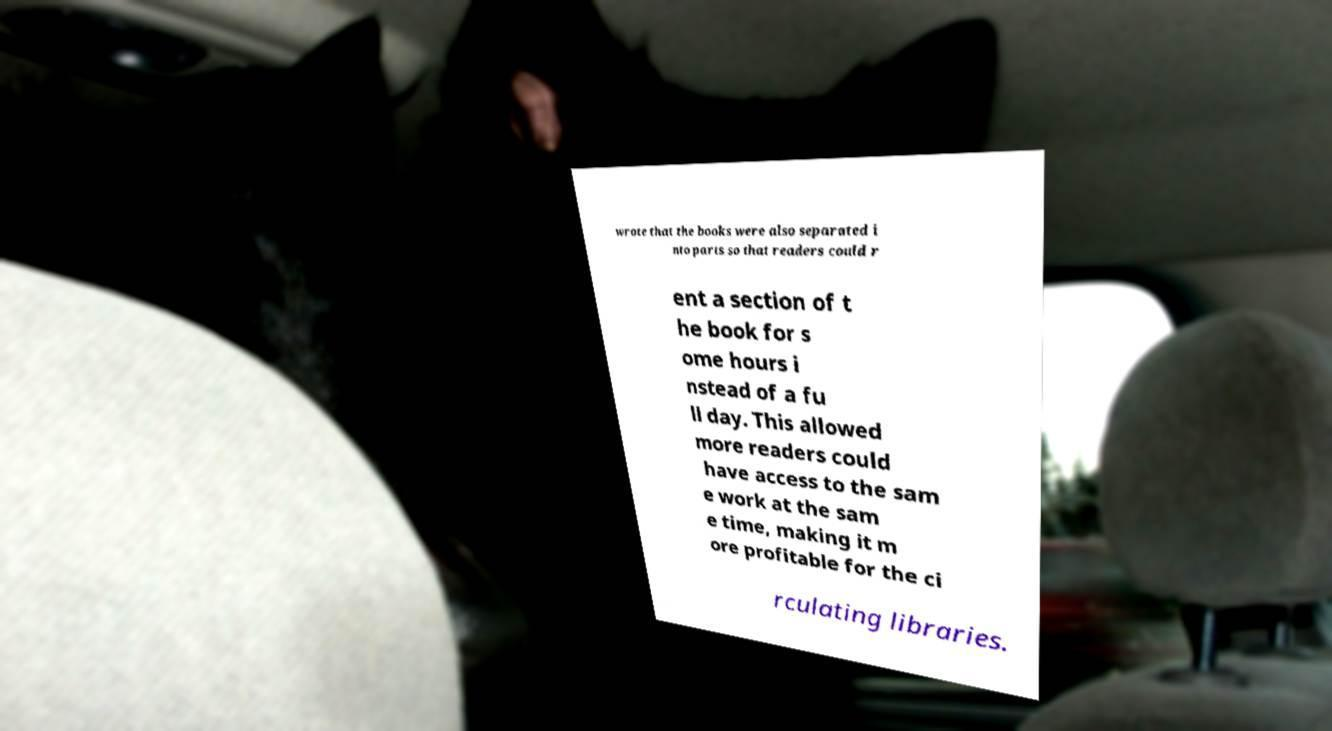Could you extract and type out the text from this image? wrote that the books were also separated i nto parts so that readers could r ent a section of t he book for s ome hours i nstead of a fu ll day. This allowed more readers could have access to the sam e work at the sam e time, making it m ore profitable for the ci rculating libraries. 